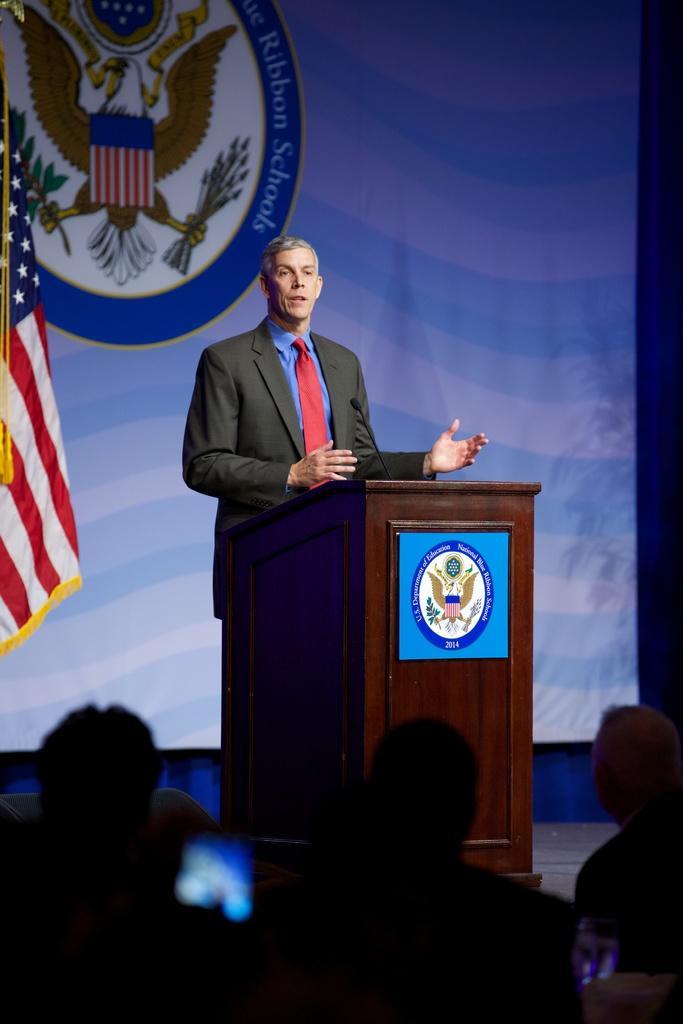Please provide a concise description of this image. In this picture I see a podium on which there is a logo and behind the podium I see a man who is standing and I see a mic on the podium. In the background I see the white color cloth on which there is a logo and something written and on the left side of this image I see a flag. 